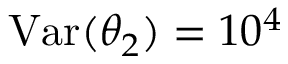<formula> <loc_0><loc_0><loc_500><loc_500>V a r ( \theta _ { 2 } ) = 1 0 ^ { 4 }</formula> 